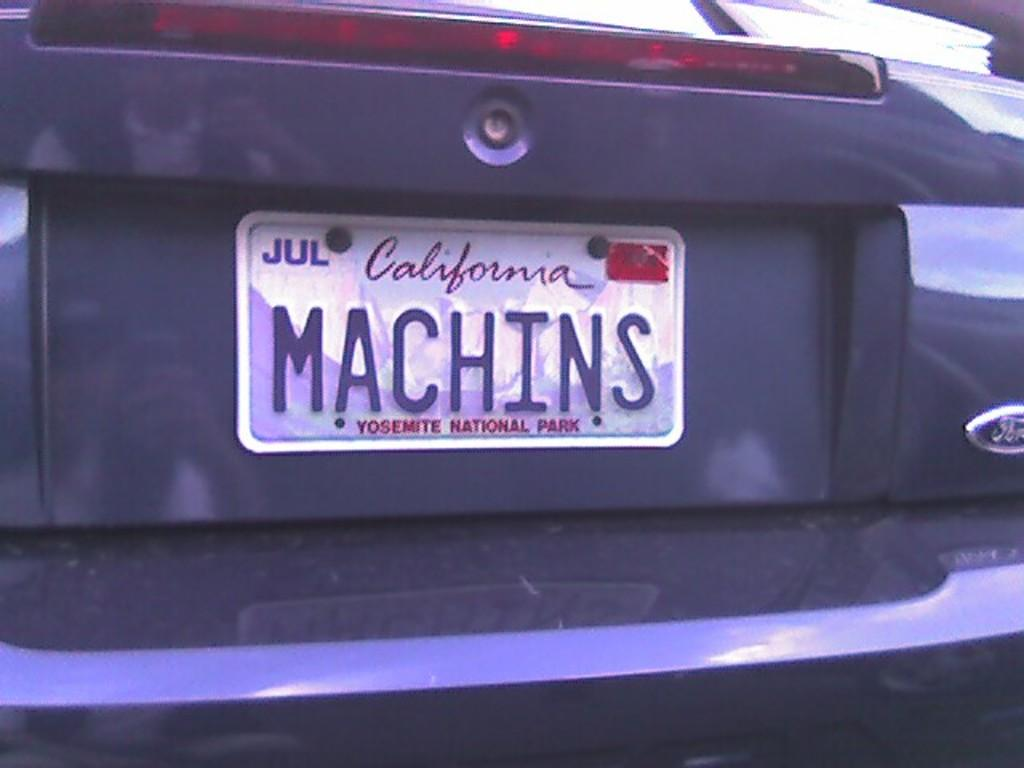<image>
Describe the image concisely. A California license plate says Yosemite National Park at the bottom. 